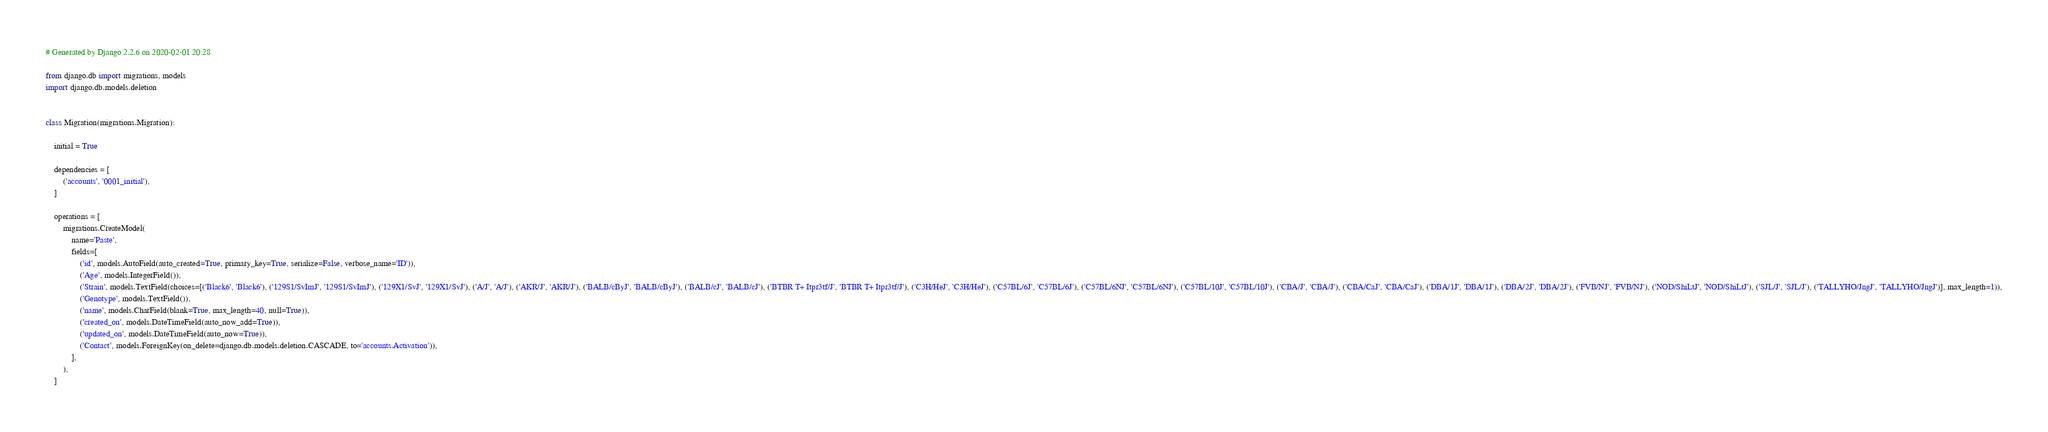Convert code to text. <code><loc_0><loc_0><loc_500><loc_500><_Python_># Generated by Django 2.2.6 on 2020-02-01 20:28

from django.db import migrations, models
import django.db.models.deletion


class Migration(migrations.Migration):

    initial = True

    dependencies = [
        ('accounts', '0001_initial'),
    ]

    operations = [
        migrations.CreateModel(
            name='Paste',
            fields=[
                ('id', models.AutoField(auto_created=True, primary_key=True, serialize=False, verbose_name='ID')),
                ('Age', models.IntegerField()),
                ('Strain', models.TextField(choices=[('Black6', 'Black6'), ('129S1/SvImJ', '129S1/SvImJ'), ('129X1/SvJ', '129X1/SvJ'), ('A/J', 'A/J'), ('AKR/J', 'AKR/J'), ('BALB/cByJ', 'BALB/cByJ'), ('BALB/cJ', 'BALB/cJ'), ('BTBR T+ Itpr3tf/J', 'BTBR T+ Itpr3tf/J'), ('C3H/HeJ', 'C3H/HeJ'), ('C57BL/6J', 'C57BL/6J'), ('C57BL/6NJ', 'C57BL/6NJ'), ('C57BL/10J', 'C57BL/10J'), ('CBA/J', 'CBA/J'), ('CBA/CaJ', 'CBA/CaJ'), ('DBA/1J', 'DBA/1J'), ('DBA/2J', 'DBA/2J'), ('FVB/NJ', 'FVB/NJ'), ('NOD/ShiLtJ', 'NOD/ShiLtJ'), ('SJL/J', 'SJL/J'), ('TALLYHO/JngJ', 'TALLYHO/JngJ')], max_length=1)),
                ('Genotype', models.TextField()),
                ('name', models.CharField(blank=True, max_length=40, null=True)),
                ('created_on', models.DateTimeField(auto_now_add=True)),
                ('updated_on', models.DateTimeField(auto_now=True)),
                ('Contact', models.ForeignKey(on_delete=django.db.models.deletion.CASCADE, to='accounts.Activation')),
            ],
        ),
    ]
</code> 